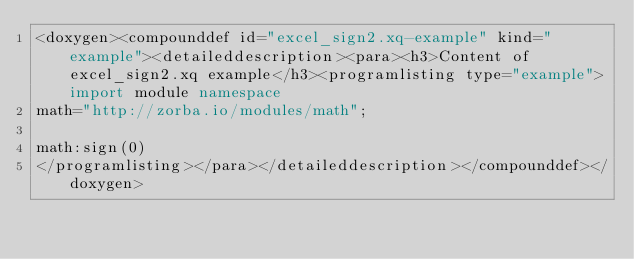<code> <loc_0><loc_0><loc_500><loc_500><_XML_><doxygen><compounddef id="excel_sign2.xq-example" kind="example"><detaileddescription><para><h3>Content of excel_sign2.xq example</h3><programlisting type="example">import module namespace
math="http://zorba.io/modules/math";

math:sign(0)
</programlisting></para></detaileddescription></compounddef></doxygen></code> 